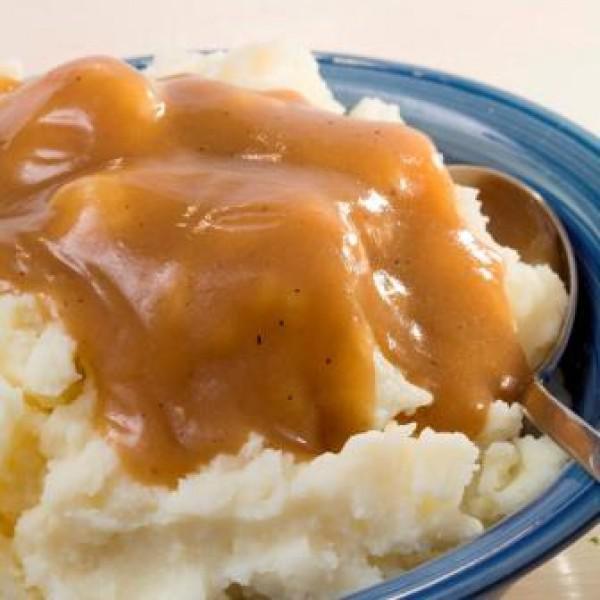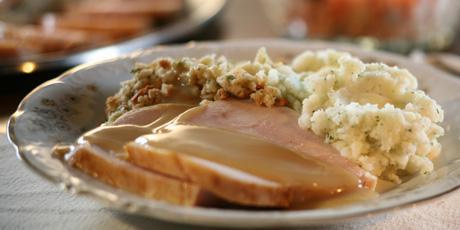The first image is the image on the left, the second image is the image on the right. Given the left and right images, does the statement "An eating utensil can be seen in the image on the left." hold true? Answer yes or no. Yes. 